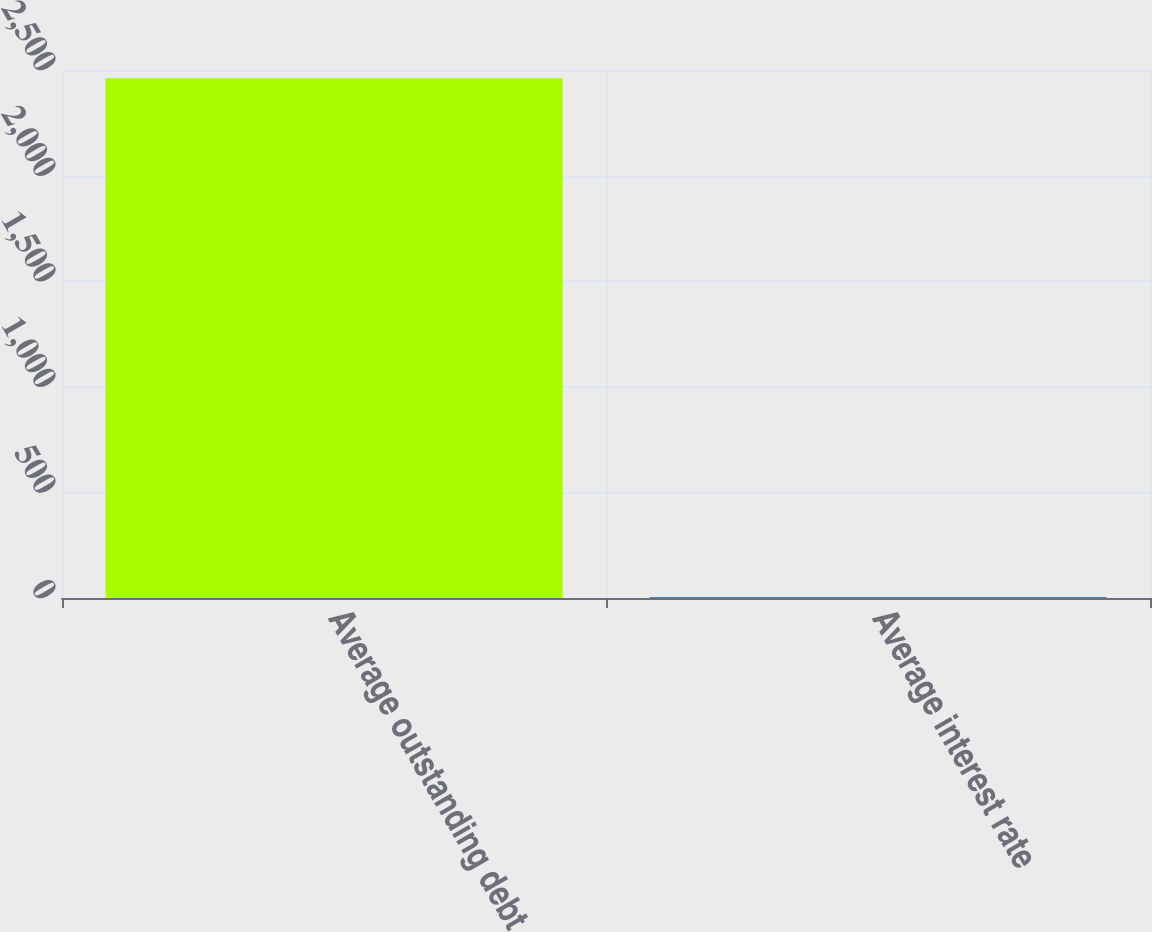<chart> <loc_0><loc_0><loc_500><loc_500><bar_chart><fcel>Average outstanding debt<fcel>Average interest rate<nl><fcel>2461<fcel>4.8<nl></chart> 